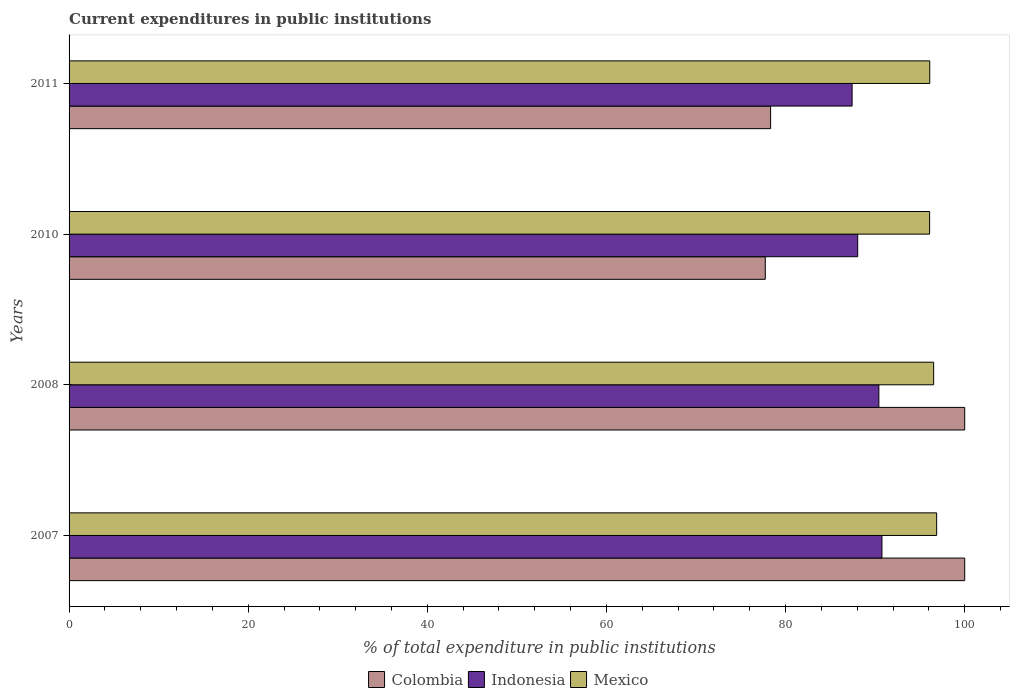What is the label of the 3rd group of bars from the top?
Make the answer very short. 2008. What is the current expenditures in public institutions in Mexico in 2011?
Keep it short and to the point. 96.1. Across all years, what is the maximum current expenditures in public institutions in Colombia?
Your answer should be compact. 100. Across all years, what is the minimum current expenditures in public institutions in Indonesia?
Offer a terse response. 87.43. In which year was the current expenditures in public institutions in Mexico maximum?
Make the answer very short. 2007. In which year was the current expenditures in public institutions in Mexico minimum?
Offer a terse response. 2010. What is the total current expenditures in public institutions in Mexico in the graph?
Your answer should be very brief. 385.58. What is the difference between the current expenditures in public institutions in Indonesia in 2007 and that in 2010?
Make the answer very short. 2.71. What is the difference between the current expenditures in public institutions in Indonesia in 2011 and the current expenditures in public institutions in Mexico in 2007?
Offer a terse response. -9.44. What is the average current expenditures in public institutions in Mexico per year?
Make the answer very short. 96.4. In the year 2008, what is the difference between the current expenditures in public institutions in Colombia and current expenditures in public institutions in Indonesia?
Offer a very short reply. 9.58. In how many years, is the current expenditures in public institutions in Mexico greater than 76 %?
Your answer should be very brief. 4. What is the ratio of the current expenditures in public institutions in Colombia in 2010 to that in 2011?
Provide a succinct answer. 0.99. Is the difference between the current expenditures in public institutions in Colombia in 2008 and 2010 greater than the difference between the current expenditures in public institutions in Indonesia in 2008 and 2010?
Offer a very short reply. Yes. What is the difference between the highest and the second highest current expenditures in public institutions in Indonesia?
Your answer should be very brief. 0.34. What is the difference between the highest and the lowest current expenditures in public institutions in Mexico?
Offer a terse response. 0.79. Is it the case that in every year, the sum of the current expenditures in public institutions in Indonesia and current expenditures in public institutions in Colombia is greater than the current expenditures in public institutions in Mexico?
Offer a terse response. Yes. Are all the bars in the graph horizontal?
Your answer should be very brief. Yes. What is the difference between two consecutive major ticks on the X-axis?
Provide a short and direct response. 20. Are the values on the major ticks of X-axis written in scientific E-notation?
Make the answer very short. No. Does the graph contain grids?
Your answer should be compact. No. What is the title of the graph?
Your response must be concise. Current expenditures in public institutions. Does "Turkey" appear as one of the legend labels in the graph?
Ensure brevity in your answer.  No. What is the label or title of the X-axis?
Give a very brief answer. % of total expenditure in public institutions. What is the % of total expenditure in public institutions of Indonesia in 2007?
Provide a succinct answer. 90.76. What is the % of total expenditure in public institutions of Mexico in 2007?
Offer a terse response. 96.87. What is the % of total expenditure in public institutions in Colombia in 2008?
Your answer should be compact. 100. What is the % of total expenditure in public institutions of Indonesia in 2008?
Make the answer very short. 90.42. What is the % of total expenditure in public institutions of Mexico in 2008?
Make the answer very short. 96.53. What is the % of total expenditure in public institutions in Colombia in 2010?
Your response must be concise. 77.73. What is the % of total expenditure in public institutions in Indonesia in 2010?
Provide a short and direct response. 88.05. What is the % of total expenditure in public institutions in Mexico in 2010?
Your response must be concise. 96.08. What is the % of total expenditure in public institutions of Colombia in 2011?
Offer a terse response. 78.33. What is the % of total expenditure in public institutions in Indonesia in 2011?
Ensure brevity in your answer.  87.43. What is the % of total expenditure in public institutions of Mexico in 2011?
Ensure brevity in your answer.  96.1. Across all years, what is the maximum % of total expenditure in public institutions in Indonesia?
Make the answer very short. 90.76. Across all years, what is the maximum % of total expenditure in public institutions of Mexico?
Offer a very short reply. 96.87. Across all years, what is the minimum % of total expenditure in public institutions of Colombia?
Give a very brief answer. 77.73. Across all years, what is the minimum % of total expenditure in public institutions of Indonesia?
Provide a short and direct response. 87.43. Across all years, what is the minimum % of total expenditure in public institutions in Mexico?
Offer a very short reply. 96.08. What is the total % of total expenditure in public institutions of Colombia in the graph?
Your answer should be compact. 356.06. What is the total % of total expenditure in public institutions in Indonesia in the graph?
Your answer should be very brief. 356.65. What is the total % of total expenditure in public institutions of Mexico in the graph?
Provide a short and direct response. 385.58. What is the difference between the % of total expenditure in public institutions of Colombia in 2007 and that in 2008?
Make the answer very short. 0. What is the difference between the % of total expenditure in public institutions of Indonesia in 2007 and that in 2008?
Provide a short and direct response. 0.34. What is the difference between the % of total expenditure in public institutions in Mexico in 2007 and that in 2008?
Offer a terse response. 0.34. What is the difference between the % of total expenditure in public institutions in Colombia in 2007 and that in 2010?
Offer a very short reply. 22.27. What is the difference between the % of total expenditure in public institutions of Indonesia in 2007 and that in 2010?
Keep it short and to the point. 2.71. What is the difference between the % of total expenditure in public institutions of Mexico in 2007 and that in 2010?
Make the answer very short. 0.79. What is the difference between the % of total expenditure in public institutions of Colombia in 2007 and that in 2011?
Offer a very short reply. 21.67. What is the difference between the % of total expenditure in public institutions in Indonesia in 2007 and that in 2011?
Your answer should be compact. 3.33. What is the difference between the % of total expenditure in public institutions in Mexico in 2007 and that in 2011?
Keep it short and to the point. 0.77. What is the difference between the % of total expenditure in public institutions of Colombia in 2008 and that in 2010?
Provide a short and direct response. 22.27. What is the difference between the % of total expenditure in public institutions of Indonesia in 2008 and that in 2010?
Offer a very short reply. 2.36. What is the difference between the % of total expenditure in public institutions in Mexico in 2008 and that in 2010?
Give a very brief answer. 0.45. What is the difference between the % of total expenditure in public institutions of Colombia in 2008 and that in 2011?
Keep it short and to the point. 21.67. What is the difference between the % of total expenditure in public institutions of Indonesia in 2008 and that in 2011?
Keep it short and to the point. 2.99. What is the difference between the % of total expenditure in public institutions in Mexico in 2008 and that in 2011?
Ensure brevity in your answer.  0.43. What is the difference between the % of total expenditure in public institutions in Colombia in 2010 and that in 2011?
Provide a short and direct response. -0.6. What is the difference between the % of total expenditure in public institutions in Indonesia in 2010 and that in 2011?
Offer a terse response. 0.63. What is the difference between the % of total expenditure in public institutions in Mexico in 2010 and that in 2011?
Give a very brief answer. -0.02. What is the difference between the % of total expenditure in public institutions of Colombia in 2007 and the % of total expenditure in public institutions of Indonesia in 2008?
Keep it short and to the point. 9.59. What is the difference between the % of total expenditure in public institutions in Colombia in 2007 and the % of total expenditure in public institutions in Mexico in 2008?
Your answer should be very brief. 3.47. What is the difference between the % of total expenditure in public institutions of Indonesia in 2007 and the % of total expenditure in public institutions of Mexico in 2008?
Your answer should be very brief. -5.77. What is the difference between the % of total expenditure in public institutions in Colombia in 2007 and the % of total expenditure in public institutions in Indonesia in 2010?
Make the answer very short. 11.95. What is the difference between the % of total expenditure in public institutions in Colombia in 2007 and the % of total expenditure in public institutions in Mexico in 2010?
Provide a short and direct response. 3.92. What is the difference between the % of total expenditure in public institutions of Indonesia in 2007 and the % of total expenditure in public institutions of Mexico in 2010?
Provide a short and direct response. -5.32. What is the difference between the % of total expenditure in public institutions of Colombia in 2007 and the % of total expenditure in public institutions of Indonesia in 2011?
Provide a succinct answer. 12.57. What is the difference between the % of total expenditure in public institutions of Colombia in 2007 and the % of total expenditure in public institutions of Mexico in 2011?
Provide a succinct answer. 3.9. What is the difference between the % of total expenditure in public institutions of Indonesia in 2007 and the % of total expenditure in public institutions of Mexico in 2011?
Your answer should be very brief. -5.34. What is the difference between the % of total expenditure in public institutions in Colombia in 2008 and the % of total expenditure in public institutions in Indonesia in 2010?
Ensure brevity in your answer.  11.95. What is the difference between the % of total expenditure in public institutions in Colombia in 2008 and the % of total expenditure in public institutions in Mexico in 2010?
Ensure brevity in your answer.  3.92. What is the difference between the % of total expenditure in public institutions of Indonesia in 2008 and the % of total expenditure in public institutions of Mexico in 2010?
Make the answer very short. -5.67. What is the difference between the % of total expenditure in public institutions in Colombia in 2008 and the % of total expenditure in public institutions in Indonesia in 2011?
Your answer should be compact. 12.57. What is the difference between the % of total expenditure in public institutions of Colombia in 2008 and the % of total expenditure in public institutions of Mexico in 2011?
Offer a very short reply. 3.9. What is the difference between the % of total expenditure in public institutions in Indonesia in 2008 and the % of total expenditure in public institutions in Mexico in 2011?
Provide a succinct answer. -5.68. What is the difference between the % of total expenditure in public institutions in Colombia in 2010 and the % of total expenditure in public institutions in Indonesia in 2011?
Provide a succinct answer. -9.69. What is the difference between the % of total expenditure in public institutions of Colombia in 2010 and the % of total expenditure in public institutions of Mexico in 2011?
Make the answer very short. -18.36. What is the difference between the % of total expenditure in public institutions in Indonesia in 2010 and the % of total expenditure in public institutions in Mexico in 2011?
Offer a terse response. -8.04. What is the average % of total expenditure in public institutions in Colombia per year?
Keep it short and to the point. 89.02. What is the average % of total expenditure in public institutions of Indonesia per year?
Provide a succinct answer. 89.16. What is the average % of total expenditure in public institutions of Mexico per year?
Offer a very short reply. 96.4. In the year 2007, what is the difference between the % of total expenditure in public institutions of Colombia and % of total expenditure in public institutions of Indonesia?
Keep it short and to the point. 9.24. In the year 2007, what is the difference between the % of total expenditure in public institutions in Colombia and % of total expenditure in public institutions in Mexico?
Give a very brief answer. 3.13. In the year 2007, what is the difference between the % of total expenditure in public institutions of Indonesia and % of total expenditure in public institutions of Mexico?
Your answer should be very brief. -6.11. In the year 2008, what is the difference between the % of total expenditure in public institutions in Colombia and % of total expenditure in public institutions in Indonesia?
Offer a terse response. 9.59. In the year 2008, what is the difference between the % of total expenditure in public institutions of Colombia and % of total expenditure in public institutions of Mexico?
Offer a terse response. 3.47. In the year 2008, what is the difference between the % of total expenditure in public institutions of Indonesia and % of total expenditure in public institutions of Mexico?
Provide a succinct answer. -6.12. In the year 2010, what is the difference between the % of total expenditure in public institutions in Colombia and % of total expenditure in public institutions in Indonesia?
Your response must be concise. -10.32. In the year 2010, what is the difference between the % of total expenditure in public institutions of Colombia and % of total expenditure in public institutions of Mexico?
Offer a very short reply. -18.35. In the year 2010, what is the difference between the % of total expenditure in public institutions in Indonesia and % of total expenditure in public institutions in Mexico?
Offer a terse response. -8.03. In the year 2011, what is the difference between the % of total expenditure in public institutions in Colombia and % of total expenditure in public institutions in Indonesia?
Offer a terse response. -9.1. In the year 2011, what is the difference between the % of total expenditure in public institutions of Colombia and % of total expenditure in public institutions of Mexico?
Provide a succinct answer. -17.77. In the year 2011, what is the difference between the % of total expenditure in public institutions of Indonesia and % of total expenditure in public institutions of Mexico?
Offer a very short reply. -8.67. What is the ratio of the % of total expenditure in public institutions of Mexico in 2007 to that in 2008?
Your answer should be compact. 1. What is the ratio of the % of total expenditure in public institutions in Colombia in 2007 to that in 2010?
Ensure brevity in your answer.  1.29. What is the ratio of the % of total expenditure in public institutions in Indonesia in 2007 to that in 2010?
Your answer should be very brief. 1.03. What is the ratio of the % of total expenditure in public institutions of Mexico in 2007 to that in 2010?
Keep it short and to the point. 1.01. What is the ratio of the % of total expenditure in public institutions in Colombia in 2007 to that in 2011?
Your response must be concise. 1.28. What is the ratio of the % of total expenditure in public institutions in Indonesia in 2007 to that in 2011?
Keep it short and to the point. 1.04. What is the ratio of the % of total expenditure in public institutions of Colombia in 2008 to that in 2010?
Offer a terse response. 1.29. What is the ratio of the % of total expenditure in public institutions in Indonesia in 2008 to that in 2010?
Make the answer very short. 1.03. What is the ratio of the % of total expenditure in public institutions of Mexico in 2008 to that in 2010?
Keep it short and to the point. 1. What is the ratio of the % of total expenditure in public institutions in Colombia in 2008 to that in 2011?
Keep it short and to the point. 1.28. What is the ratio of the % of total expenditure in public institutions in Indonesia in 2008 to that in 2011?
Your answer should be compact. 1.03. What is the ratio of the % of total expenditure in public institutions in Mexico in 2008 to that in 2011?
Provide a succinct answer. 1. What is the ratio of the % of total expenditure in public institutions of Indonesia in 2010 to that in 2011?
Your response must be concise. 1.01. What is the difference between the highest and the second highest % of total expenditure in public institutions in Colombia?
Keep it short and to the point. 0. What is the difference between the highest and the second highest % of total expenditure in public institutions in Indonesia?
Ensure brevity in your answer.  0.34. What is the difference between the highest and the second highest % of total expenditure in public institutions of Mexico?
Give a very brief answer. 0.34. What is the difference between the highest and the lowest % of total expenditure in public institutions in Colombia?
Make the answer very short. 22.27. What is the difference between the highest and the lowest % of total expenditure in public institutions of Indonesia?
Ensure brevity in your answer.  3.33. What is the difference between the highest and the lowest % of total expenditure in public institutions in Mexico?
Make the answer very short. 0.79. 